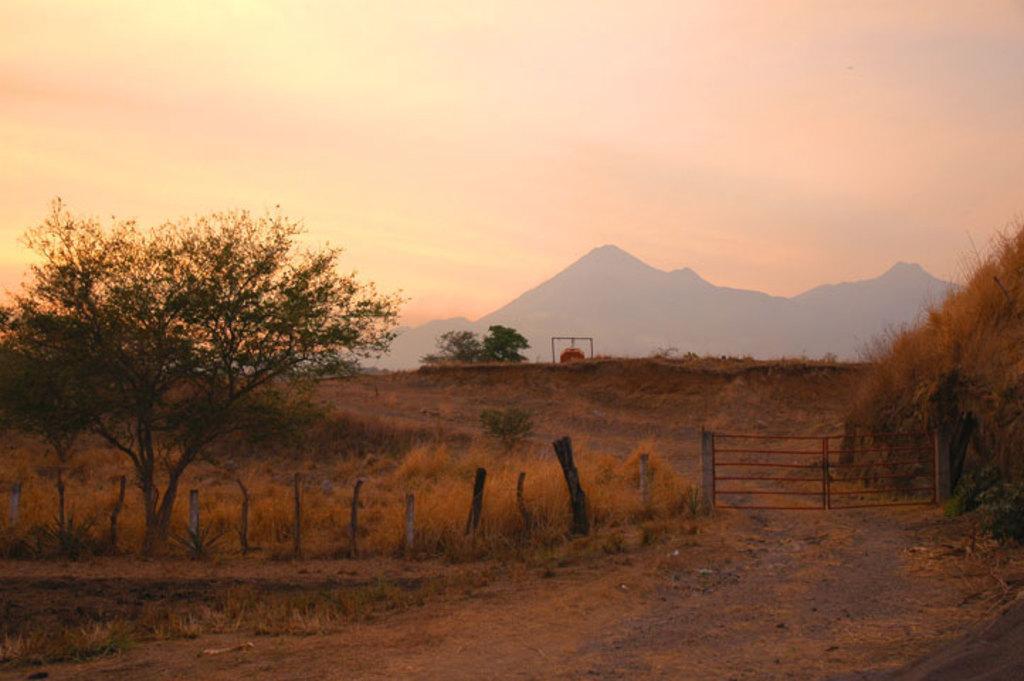Can you describe this image briefly? In this image on the left side we can see a tree, grass and wooden poles. We can see the gate and grass on the right side. In the background we can see trees, an object, mountains and clouds in the sky. 